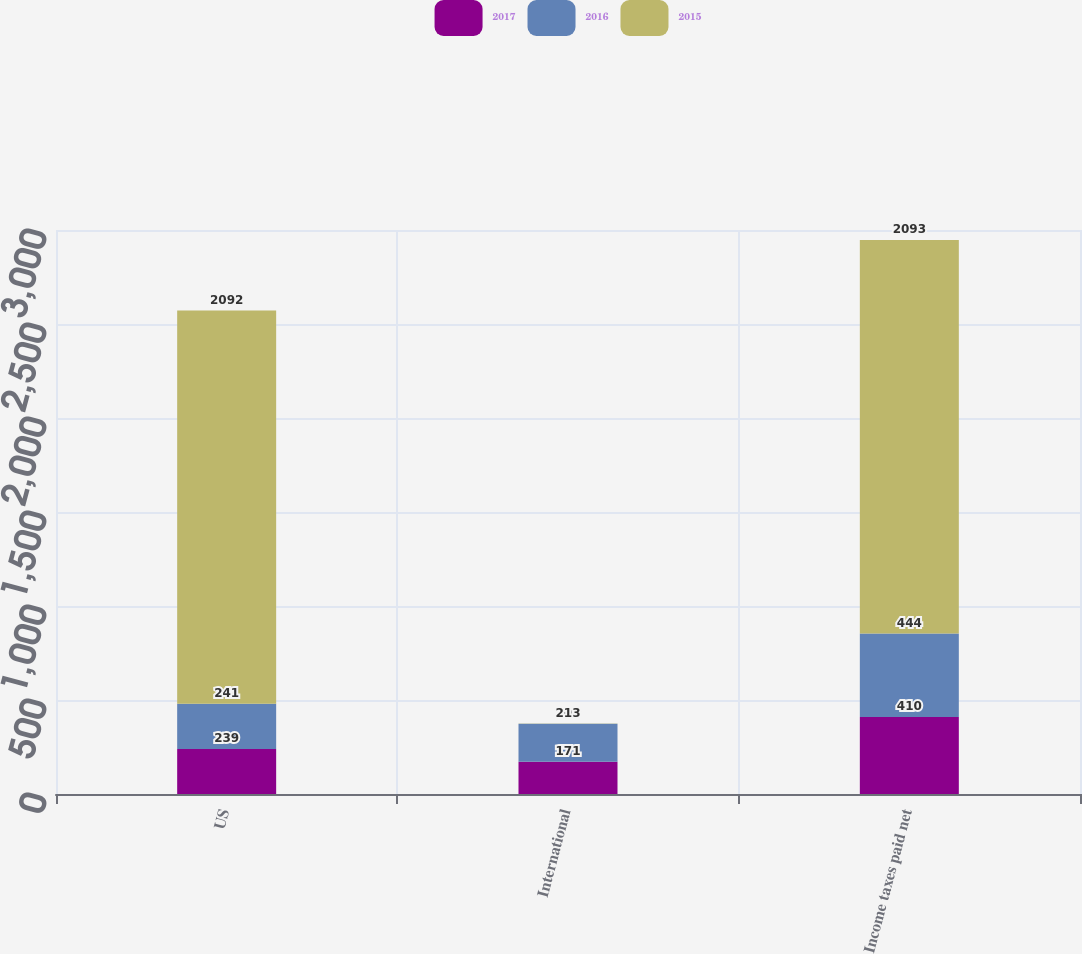Convert chart. <chart><loc_0><loc_0><loc_500><loc_500><stacked_bar_chart><ecel><fcel>US<fcel>International<fcel>Income taxes paid net<nl><fcel>2017<fcel>239<fcel>171<fcel>410<nl><fcel>2016<fcel>241<fcel>203<fcel>444<nl><fcel>2015<fcel>2092<fcel>1<fcel>2093<nl></chart> 